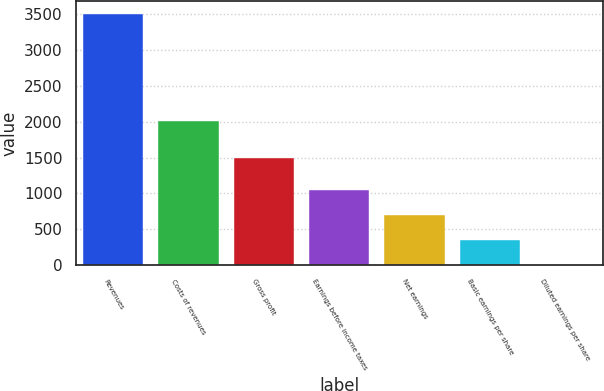Convert chart. <chart><loc_0><loc_0><loc_500><loc_500><bar_chart><fcel>Revenues<fcel>Costs of revenues<fcel>Gross profit<fcel>Earnings before income taxes<fcel>Net earnings<fcel>Basic earnings per share<fcel>Diluted earnings per share<nl><fcel>3505.9<fcel>2013.7<fcel>1492.2<fcel>1052.65<fcel>702.19<fcel>351.73<fcel>1.27<nl></chart> 